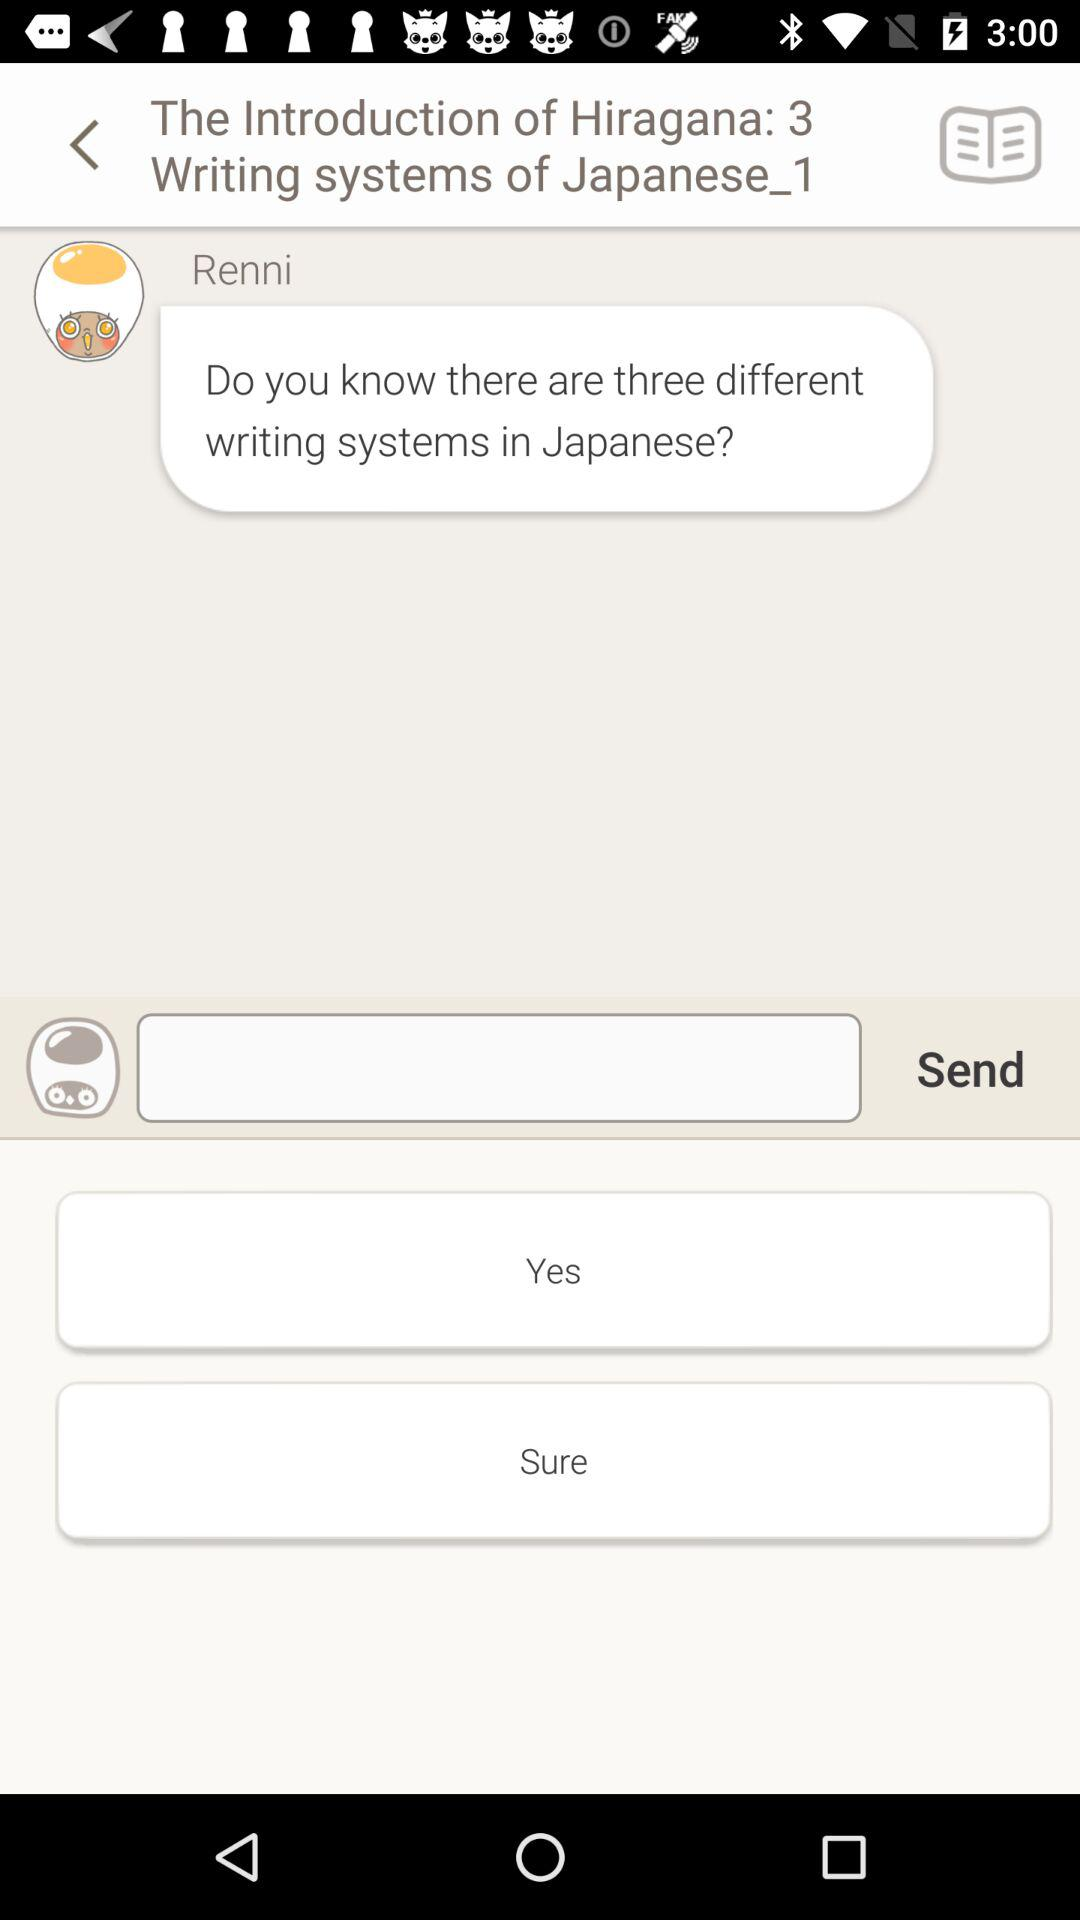Which response option is selected?
When the provided information is insufficient, respond with <no answer>. <no answer> 